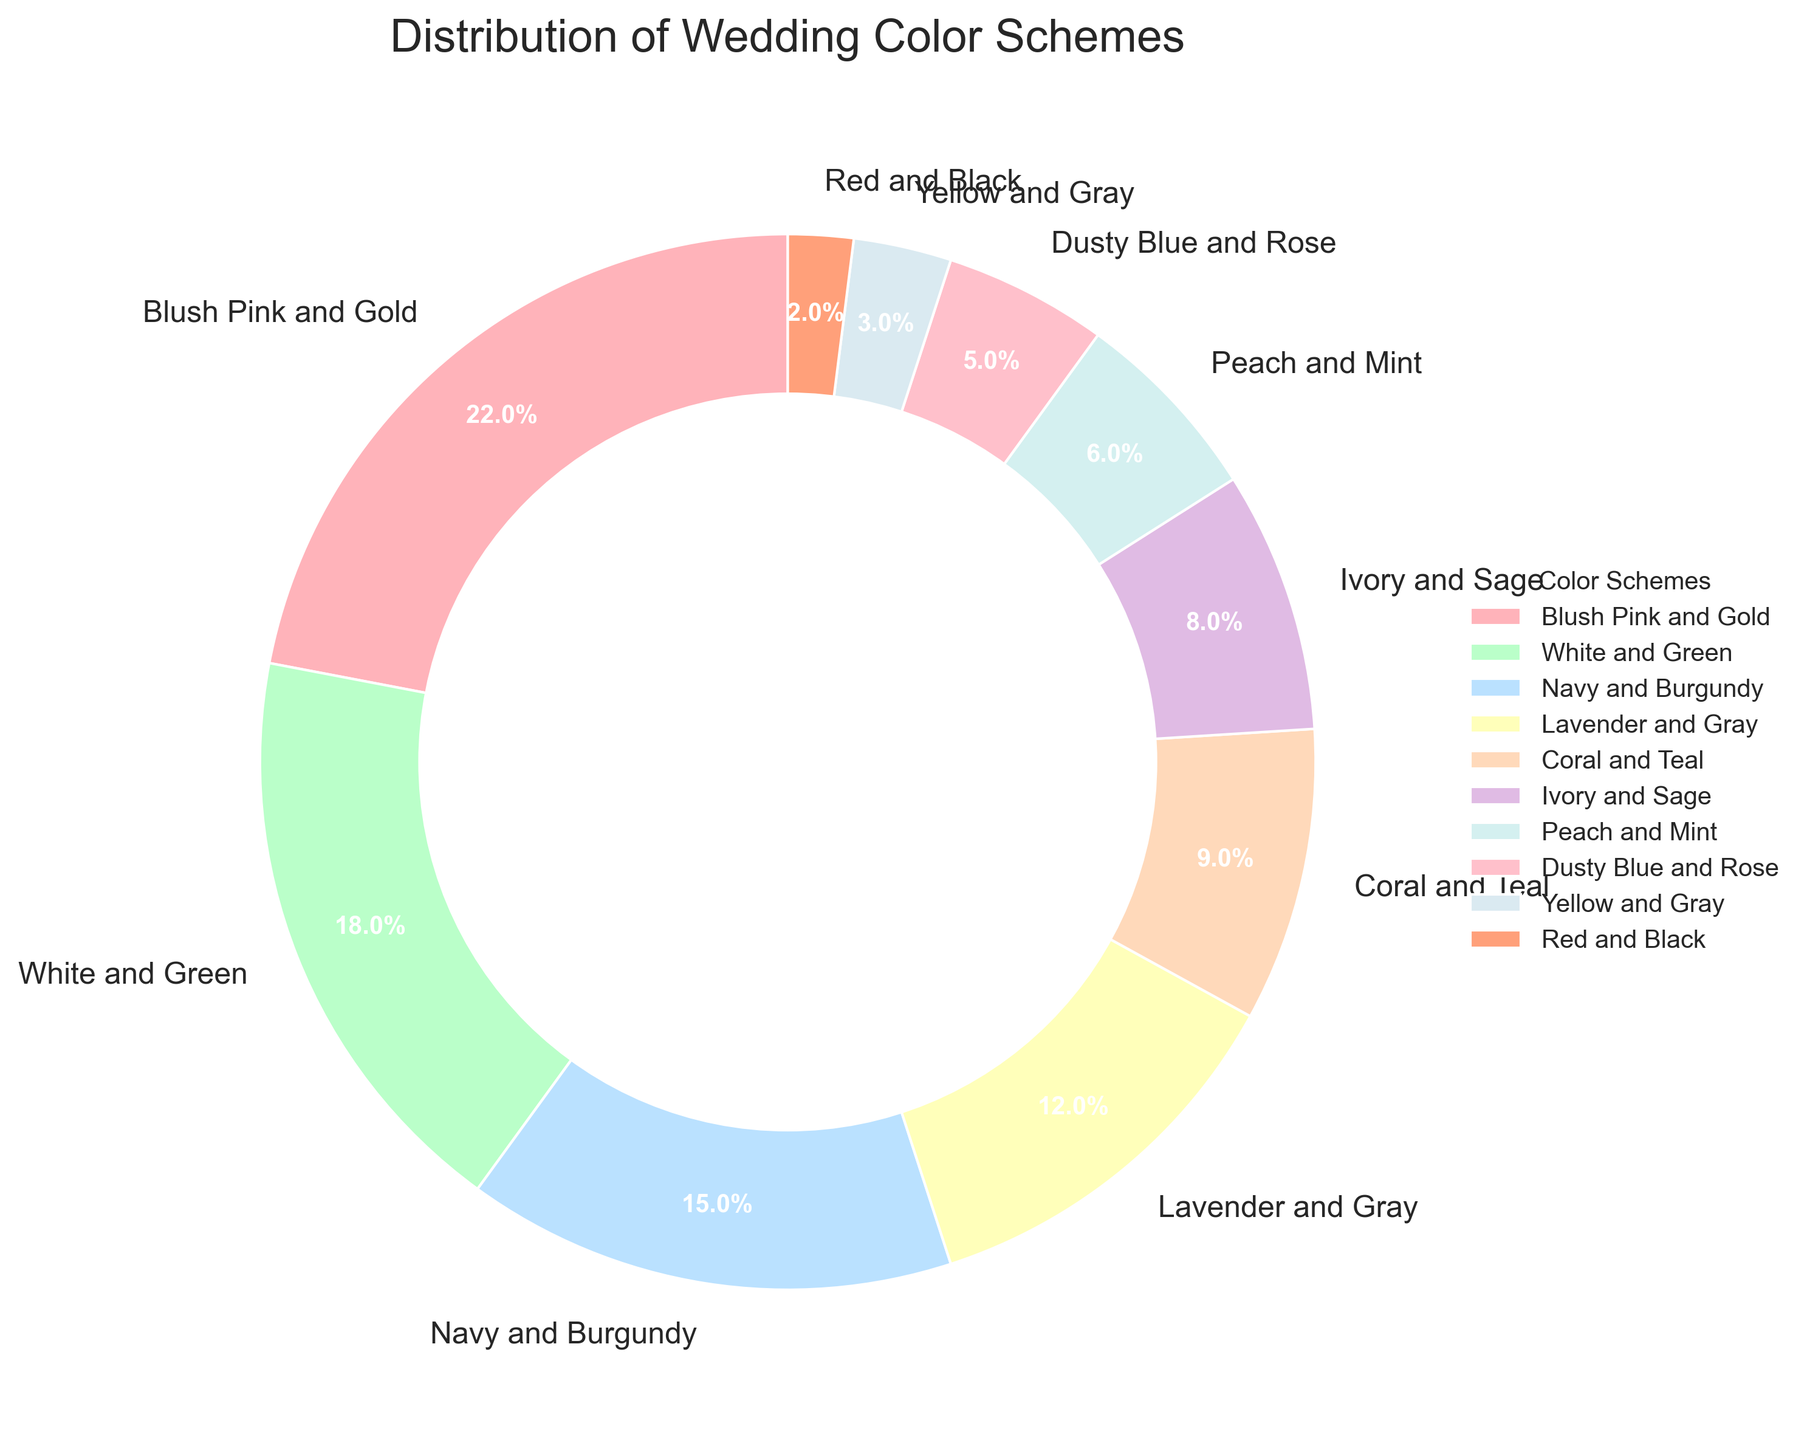What is the most preferred wedding color scheme according to the chart? The chart shows the distribution of wedding color schemes preferred by brides. The segment for "Blush Pink and Gold" is the largest, indicating it has the highest percentage.
Answer: Blush Pink and Gold Which color scheme is preferred more: Navy and Burgundy or Ivory and Sage? By comparing the chart's segments, Navy and Burgundy has a larger segment (15%) than Ivory and Sage (8%).
Answer: Navy and Burgundy What is the sum of the percentages for the three least preferred color schemes? The least preferred schemes are Red and Black (2%), Yellow and Gray (3%), and Dusty Blue and Rose (5%). Adding these gives: 2% + 3% + 5% = 10%.
Answer: 10% Which color scheme is exactly in the middle in terms of preference percentage? There are ten segments. The fifth and sixth color schemes from a sorted list are Coral and Teal (9%) and Ivory and Sage (8%). Considering the total number of segments, Ivory and Sage is exactly in the middle.
Answer: Ivory and Sage How many color schemes have a preference percentage of 10% or more? The color schemes above 10% are Blush Pink and Gold (22%), White and Green (18%), Navy and Burgundy (15%), and Lavender and Gray (12%), which sums up to four color schemes.
Answer: 4 What is the difference in percentage between the most and least preferred wedding color schemes? The most preferred scheme is Blush Pink and Gold (22%), and the least preferred is Red and Black (2%). The difference is 22% - 2% = 20%.
Answer: 20% Which color scheme occupies the smallest segment and what is its percentage? The Red and Black color scheme segment is the smallest in size, corresponding to a 2% preference.
Answer: Red and Black, 2% How does the preference for Peach and Mint compare to Coral and Teal? Peach and Mint has a percentage of 6%, while Coral and Teal has 9%. Coral and Teal is preferred more than Peach and Mint.
Answer: Coral and Teal is preferred more What is the total percentage for the schemes that are preferred by 15% or more of the brides? The schemes preferred by 15% or more are Blush Pink and Gold (22%), White and Green (18%), and Navy and Burgundy (15%). Adding these gives: 22% + 18% + 15% = 55%.
Answer: 55% Which color scheme has a preference percentage that is closest to 10% but not exceeding it? Coral and Teal has a preference percentage of 9%, which is closest to but not exceeding 10%.
Answer: Coral and Teal 